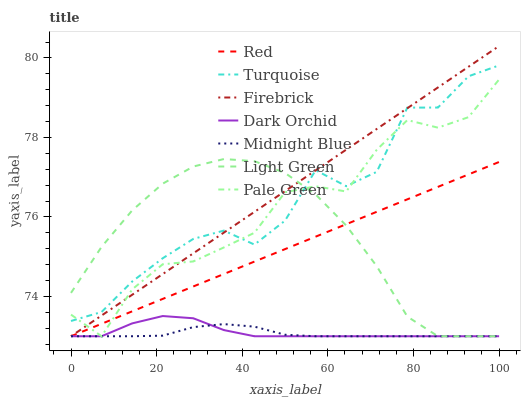Does Midnight Blue have the minimum area under the curve?
Answer yes or no. Yes. Does Firebrick have the maximum area under the curve?
Answer yes or no. Yes. Does Firebrick have the minimum area under the curve?
Answer yes or no. No. Does Midnight Blue have the maximum area under the curve?
Answer yes or no. No. Is Red the smoothest?
Answer yes or no. Yes. Is Turquoise the roughest?
Answer yes or no. Yes. Is Midnight Blue the smoothest?
Answer yes or no. No. Is Midnight Blue the roughest?
Answer yes or no. No. Does Firebrick have the highest value?
Answer yes or no. Yes. Does Midnight Blue have the highest value?
Answer yes or no. No. Is Midnight Blue less than Turquoise?
Answer yes or no. Yes. Is Turquoise greater than Red?
Answer yes or no. Yes. Does Red intersect Midnight Blue?
Answer yes or no. Yes. Is Red less than Midnight Blue?
Answer yes or no. No. Is Red greater than Midnight Blue?
Answer yes or no. No. Does Midnight Blue intersect Turquoise?
Answer yes or no. No. 